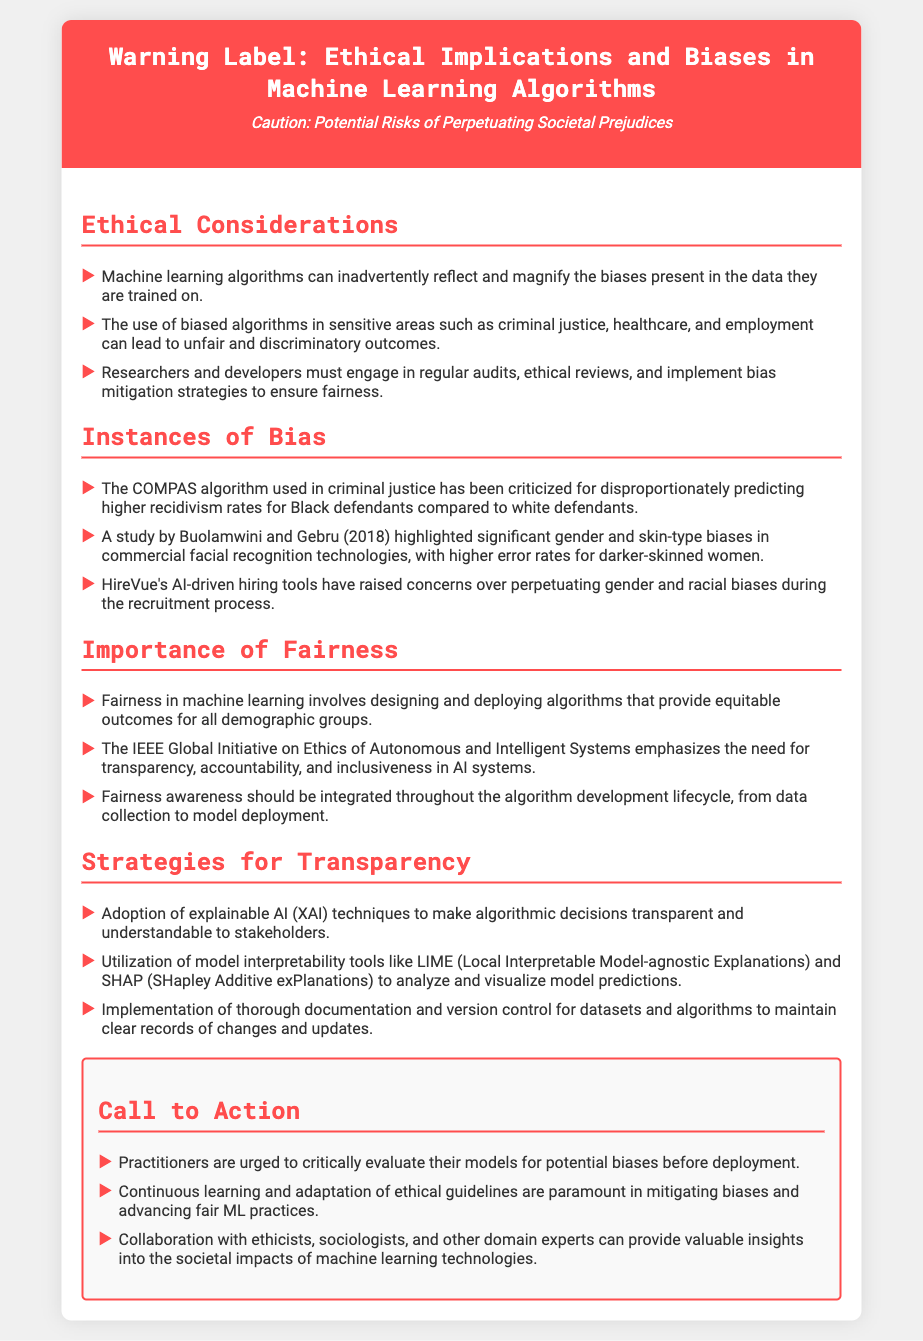What is the title of the document? The title is stated in the header section of the document.
Answer: Warning Label: Ethical Implications and Biases in Machine Learning Algorithms What algorithm is criticized in the document for bias in criminal justice? The algorithm is mentioned in the "Instances of Bias" section that discusses its criticism.
Answer: COMPAS Which study revealed gender and skin-type biases in facial recognition technology? The document details the study in the "Instances of Bias" section.
Answer: Buolamwini and Gebru (2018) What color is the header background in the document? The header section's styling details are included in the CSS part of the document.
Answer: #ff4d4d What is emphasized as necessary by the IEEE Global Initiative on Ethics? The relevant point is found in the "Importance of Fairness" section.
Answer: Transparency, accountability, and inclusiveness What are practitioners urged to evaluate? This recommendation is found in the "Call to Action" section.
Answer: Models for potential biases Which techniques are suggested for making algorithmic decisions transparent? This information is located in the "Strategies for Transparency" section.
Answer: Explainable AI (XAI) What do continuous learning and adaptation help with? This point is stated in the "Call to Action" section of the document.
Answer: Mitigating biases 